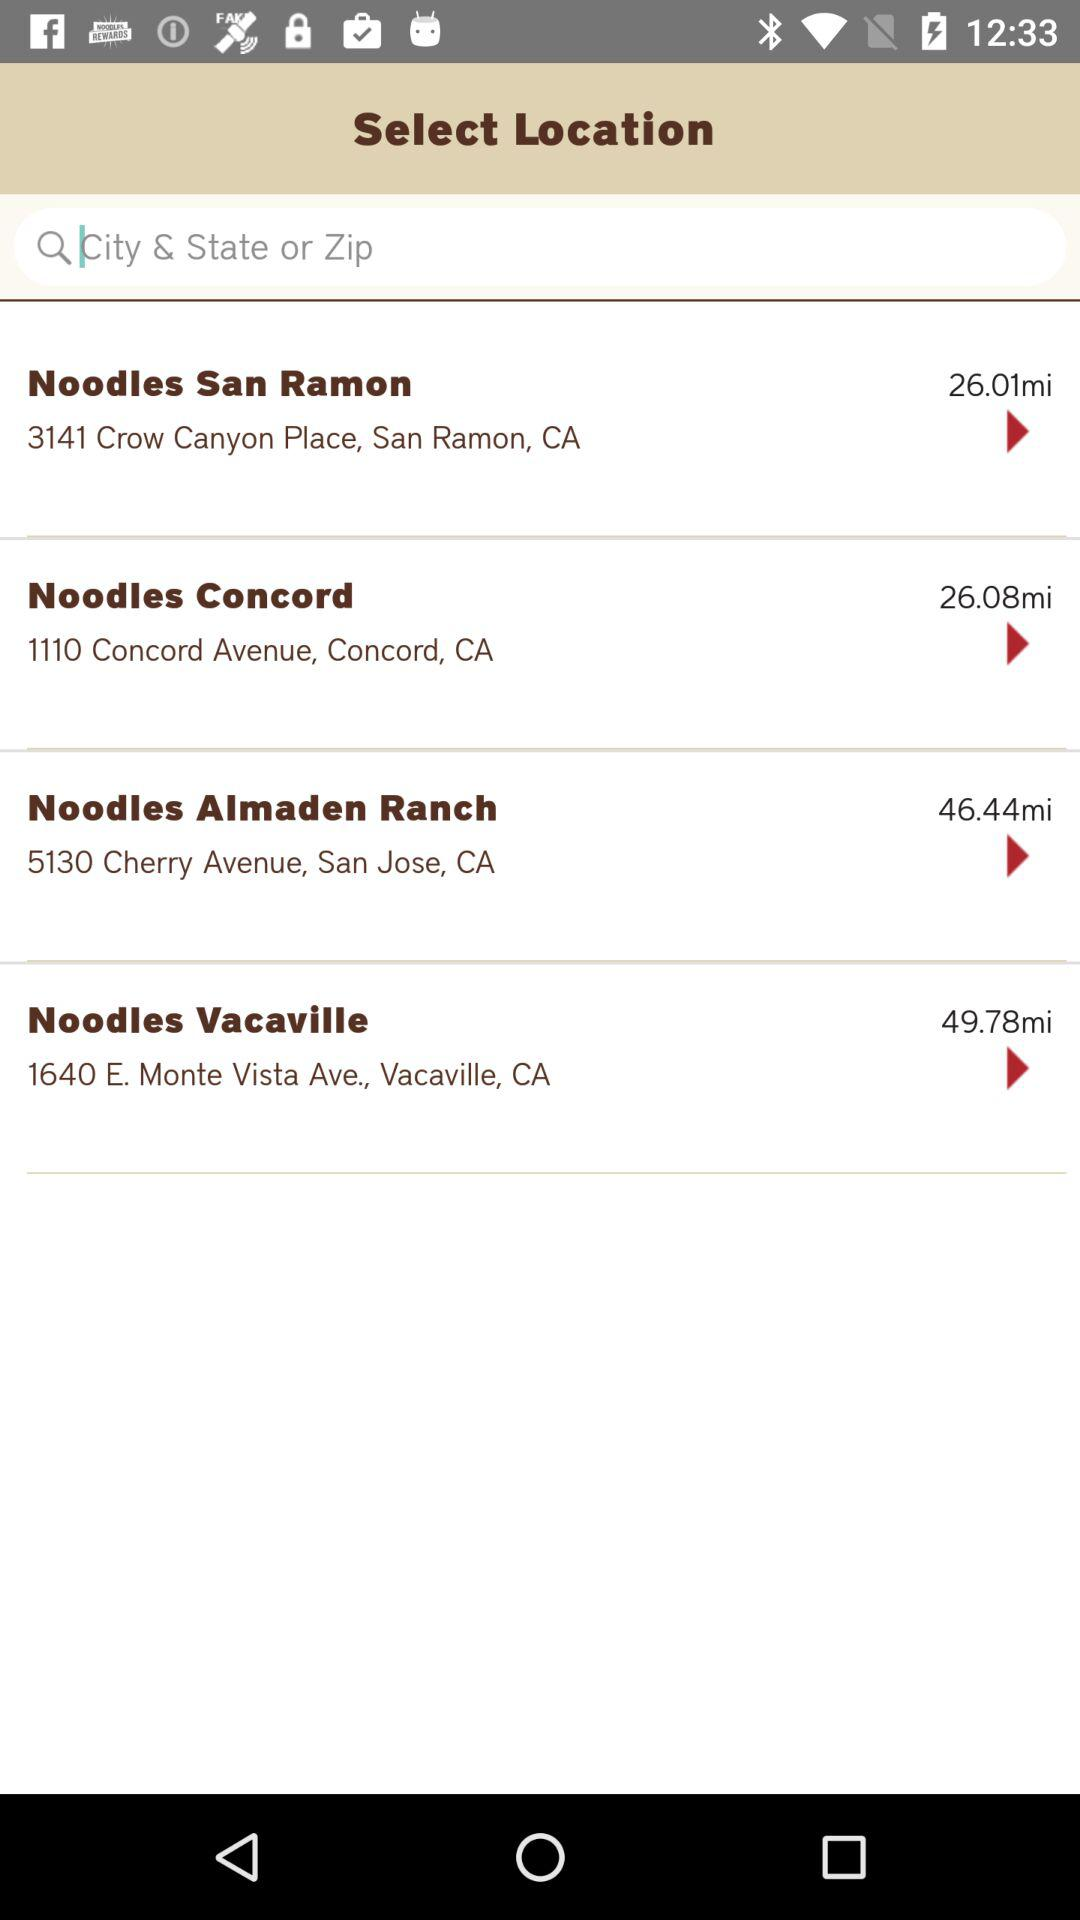What is the address of Noodles Almaden Ranch? The address of Noodles Almaden Ranch is 5130 Cherry Avenue, San Jose, CA. 